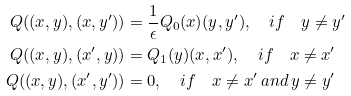<formula> <loc_0><loc_0><loc_500><loc_500>Q ( ( x , y ) , ( x , y ^ { \prime } ) ) & = \frac { 1 } { \epsilon } Q _ { 0 } ( x ) ( y , y ^ { \prime } ) , \quad i f \quad y \neq y ^ { \prime } \\ Q ( ( x , y ) , ( x ^ { \prime } , y ) ) & = Q _ { 1 } ( y ) ( x , x ^ { \prime } ) , \quad i f \quad x \neq x ^ { \prime } \\ Q ( ( x , y ) , ( x ^ { \prime } , y ^ { \prime } ) ) & = 0 , \quad i f \quad x \neq x ^ { \prime } \, a n d \, y \neq y ^ { \prime }</formula> 